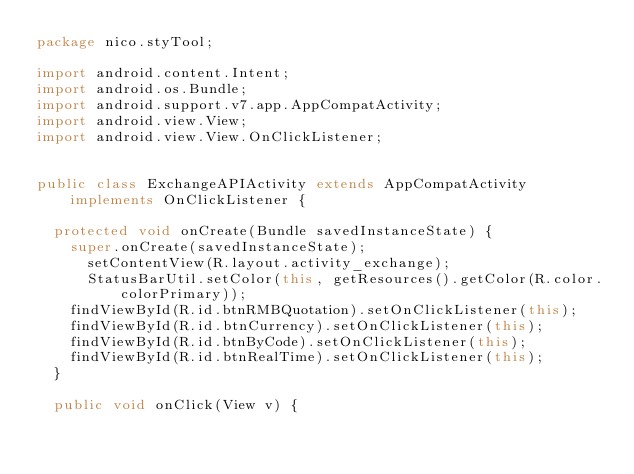Convert code to text. <code><loc_0><loc_0><loc_500><loc_500><_Java_>package nico.styTool;

import android.content.Intent;
import android.os.Bundle;
import android.support.v7.app.AppCompatActivity;
import android.view.View;
import android.view.View.OnClickListener;


public class ExchangeAPIActivity extends AppCompatActivity implements OnClickListener {

	protected void onCreate(Bundle savedInstanceState) {
		super.onCreate(savedInstanceState);
	    setContentView(R.layout.activity_exchange);
	    StatusBarUtil.setColor(this, getResources().getColor(R.color.colorPrimary));
		findViewById(R.id.btnRMBQuotation).setOnClickListener(this);
		findViewById(R.id.btnCurrency).setOnClickListener(this);
		findViewById(R.id.btnByCode).setOnClickListener(this);
		findViewById(R.id.btnRealTime).setOnClickListener(this);
	}

	public void onClick(View v) {</code> 